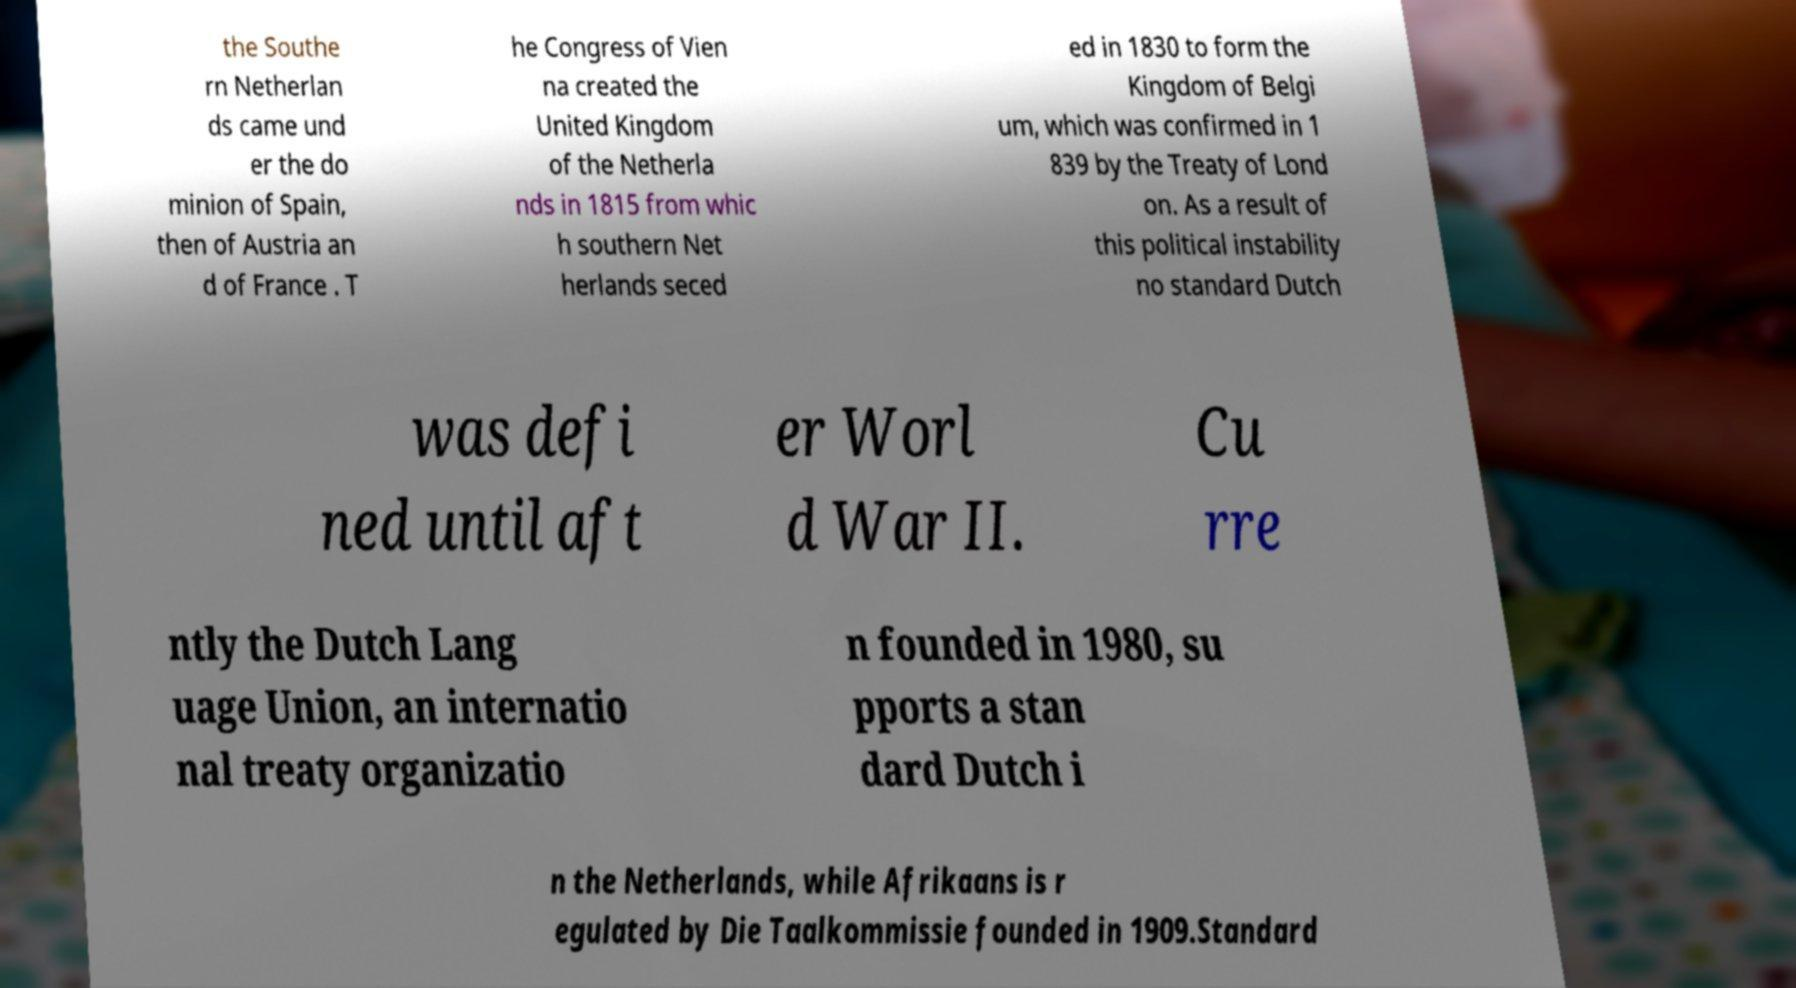Could you extract and type out the text from this image? the Southe rn Netherlan ds came und er the do minion of Spain, then of Austria an d of France . T he Congress of Vien na created the United Kingdom of the Netherla nds in 1815 from whic h southern Net herlands seced ed in 1830 to form the Kingdom of Belgi um, which was confirmed in 1 839 by the Treaty of Lond on. As a result of this political instability no standard Dutch was defi ned until aft er Worl d War II. Cu rre ntly the Dutch Lang uage Union, an internatio nal treaty organizatio n founded in 1980, su pports a stan dard Dutch i n the Netherlands, while Afrikaans is r egulated by Die Taalkommissie founded in 1909.Standard 